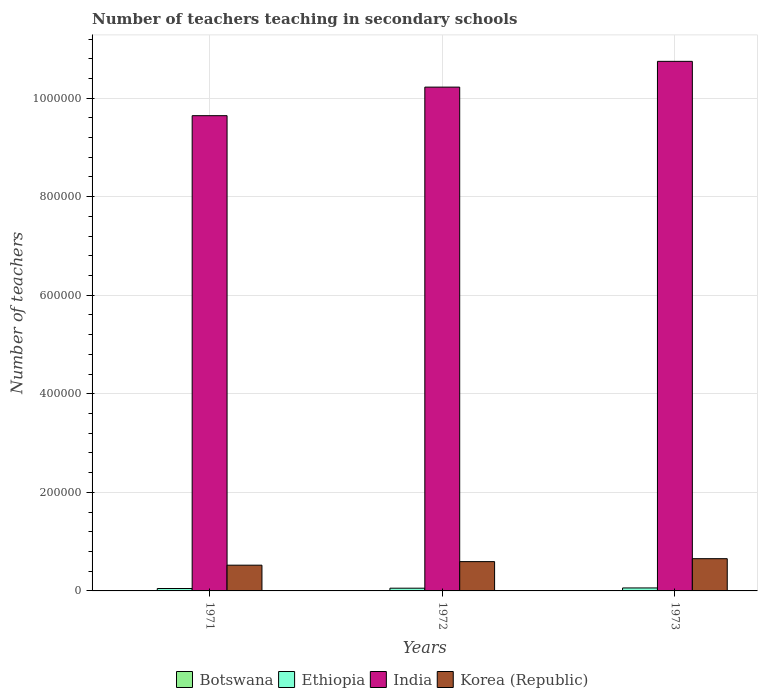How many different coloured bars are there?
Your response must be concise. 4. Are the number of bars per tick equal to the number of legend labels?
Keep it short and to the point. Yes. Are the number of bars on each tick of the X-axis equal?
Your answer should be very brief. Yes. How many bars are there on the 2nd tick from the left?
Provide a short and direct response. 4. How many bars are there on the 1st tick from the right?
Provide a succinct answer. 4. In how many cases, is the number of bars for a given year not equal to the number of legend labels?
Ensure brevity in your answer.  0. What is the number of teachers teaching in secondary schools in Korea (Republic) in 1972?
Provide a succinct answer. 5.95e+04. Across all years, what is the maximum number of teachers teaching in secondary schools in India?
Give a very brief answer. 1.07e+06. Across all years, what is the minimum number of teachers teaching in secondary schools in Ethiopia?
Offer a terse response. 4885. What is the total number of teachers teaching in secondary schools in Korea (Republic) in the graph?
Offer a terse response. 1.77e+05. What is the difference between the number of teachers teaching in secondary schools in Ethiopia in 1972 and that in 1973?
Your answer should be compact. -510. What is the difference between the number of teachers teaching in secondary schools in Ethiopia in 1973 and the number of teachers teaching in secondary schools in Korea (Republic) in 1972?
Your response must be concise. -5.34e+04. What is the average number of teachers teaching in secondary schools in India per year?
Offer a terse response. 1.02e+06. In the year 1971, what is the difference between the number of teachers teaching in secondary schools in India and number of teachers teaching in secondary schools in Ethiopia?
Your answer should be compact. 9.60e+05. In how many years, is the number of teachers teaching in secondary schools in India greater than 880000?
Ensure brevity in your answer.  3. What is the ratio of the number of teachers teaching in secondary schools in Botswana in 1972 to that in 1973?
Your answer should be compact. 0.8. What is the difference between the highest and the second highest number of teachers teaching in secondary schools in Botswana?
Your response must be concise. 119. What is the difference between the highest and the lowest number of teachers teaching in secondary schools in Korea (Republic)?
Your answer should be compact. 1.32e+04. In how many years, is the number of teachers teaching in secondary schools in Korea (Republic) greater than the average number of teachers teaching in secondary schools in Korea (Republic) taken over all years?
Provide a short and direct response. 2. Is the sum of the number of teachers teaching in secondary schools in Ethiopia in 1971 and 1972 greater than the maximum number of teachers teaching in secondary schools in Botswana across all years?
Your answer should be compact. Yes. What does the 3rd bar from the left in 1973 represents?
Provide a short and direct response. India. What does the 3rd bar from the right in 1971 represents?
Offer a very short reply. Ethiopia. Is it the case that in every year, the sum of the number of teachers teaching in secondary schools in Korea (Republic) and number of teachers teaching in secondary schools in Botswana is greater than the number of teachers teaching in secondary schools in Ethiopia?
Your answer should be compact. Yes. How many bars are there?
Your answer should be very brief. 12. Are all the bars in the graph horizontal?
Your answer should be very brief. No. How many years are there in the graph?
Your response must be concise. 3. What is the difference between two consecutive major ticks on the Y-axis?
Offer a very short reply. 2.00e+05. Does the graph contain grids?
Provide a short and direct response. Yes. Where does the legend appear in the graph?
Offer a terse response. Bottom center. How are the legend labels stacked?
Offer a terse response. Horizontal. What is the title of the graph?
Make the answer very short. Number of teachers teaching in secondary schools. What is the label or title of the Y-axis?
Provide a short and direct response. Number of teachers. What is the Number of teachers of Botswana in 1971?
Ensure brevity in your answer.  420. What is the Number of teachers of Ethiopia in 1971?
Give a very brief answer. 4885. What is the Number of teachers in India in 1971?
Give a very brief answer. 9.64e+05. What is the Number of teachers in Korea (Republic) in 1971?
Ensure brevity in your answer.  5.22e+04. What is the Number of teachers in Botswana in 1972?
Provide a succinct answer. 478. What is the Number of teachers in Ethiopia in 1972?
Offer a terse response. 5544. What is the Number of teachers of India in 1972?
Your answer should be very brief. 1.02e+06. What is the Number of teachers in Korea (Republic) in 1972?
Ensure brevity in your answer.  5.95e+04. What is the Number of teachers in Botswana in 1973?
Your answer should be compact. 597. What is the Number of teachers in Ethiopia in 1973?
Give a very brief answer. 6054. What is the Number of teachers in India in 1973?
Make the answer very short. 1.07e+06. What is the Number of teachers in Korea (Republic) in 1973?
Provide a succinct answer. 6.54e+04. Across all years, what is the maximum Number of teachers in Botswana?
Ensure brevity in your answer.  597. Across all years, what is the maximum Number of teachers of Ethiopia?
Provide a succinct answer. 6054. Across all years, what is the maximum Number of teachers in India?
Provide a succinct answer. 1.07e+06. Across all years, what is the maximum Number of teachers of Korea (Republic)?
Offer a terse response. 6.54e+04. Across all years, what is the minimum Number of teachers in Botswana?
Your response must be concise. 420. Across all years, what is the minimum Number of teachers of Ethiopia?
Keep it short and to the point. 4885. Across all years, what is the minimum Number of teachers in India?
Offer a terse response. 9.64e+05. Across all years, what is the minimum Number of teachers in Korea (Republic)?
Ensure brevity in your answer.  5.22e+04. What is the total Number of teachers in Botswana in the graph?
Offer a very short reply. 1495. What is the total Number of teachers of Ethiopia in the graph?
Provide a succinct answer. 1.65e+04. What is the total Number of teachers in India in the graph?
Your answer should be compact. 3.06e+06. What is the total Number of teachers in Korea (Republic) in the graph?
Your response must be concise. 1.77e+05. What is the difference between the Number of teachers of Botswana in 1971 and that in 1972?
Provide a succinct answer. -58. What is the difference between the Number of teachers in Ethiopia in 1971 and that in 1972?
Keep it short and to the point. -659. What is the difference between the Number of teachers in India in 1971 and that in 1972?
Offer a very short reply. -5.80e+04. What is the difference between the Number of teachers of Korea (Republic) in 1971 and that in 1972?
Ensure brevity in your answer.  -7222. What is the difference between the Number of teachers in Botswana in 1971 and that in 1973?
Ensure brevity in your answer.  -177. What is the difference between the Number of teachers of Ethiopia in 1971 and that in 1973?
Your answer should be compact. -1169. What is the difference between the Number of teachers in India in 1971 and that in 1973?
Provide a short and direct response. -1.10e+05. What is the difference between the Number of teachers in Korea (Republic) in 1971 and that in 1973?
Ensure brevity in your answer.  -1.32e+04. What is the difference between the Number of teachers of Botswana in 1972 and that in 1973?
Provide a short and direct response. -119. What is the difference between the Number of teachers of Ethiopia in 1972 and that in 1973?
Your answer should be very brief. -510. What is the difference between the Number of teachers in India in 1972 and that in 1973?
Provide a short and direct response. -5.23e+04. What is the difference between the Number of teachers in Korea (Republic) in 1972 and that in 1973?
Ensure brevity in your answer.  -5988. What is the difference between the Number of teachers in Botswana in 1971 and the Number of teachers in Ethiopia in 1972?
Your answer should be very brief. -5124. What is the difference between the Number of teachers in Botswana in 1971 and the Number of teachers in India in 1972?
Ensure brevity in your answer.  -1.02e+06. What is the difference between the Number of teachers in Botswana in 1971 and the Number of teachers in Korea (Republic) in 1972?
Provide a succinct answer. -5.90e+04. What is the difference between the Number of teachers of Ethiopia in 1971 and the Number of teachers of India in 1972?
Offer a terse response. -1.02e+06. What is the difference between the Number of teachers of Ethiopia in 1971 and the Number of teachers of Korea (Republic) in 1972?
Keep it short and to the point. -5.46e+04. What is the difference between the Number of teachers in India in 1971 and the Number of teachers in Korea (Republic) in 1972?
Give a very brief answer. 9.05e+05. What is the difference between the Number of teachers in Botswana in 1971 and the Number of teachers in Ethiopia in 1973?
Provide a short and direct response. -5634. What is the difference between the Number of teachers in Botswana in 1971 and the Number of teachers in India in 1973?
Keep it short and to the point. -1.07e+06. What is the difference between the Number of teachers in Botswana in 1971 and the Number of teachers in Korea (Republic) in 1973?
Keep it short and to the point. -6.50e+04. What is the difference between the Number of teachers in Ethiopia in 1971 and the Number of teachers in India in 1973?
Your answer should be compact. -1.07e+06. What is the difference between the Number of teachers of Ethiopia in 1971 and the Number of teachers of Korea (Republic) in 1973?
Ensure brevity in your answer.  -6.06e+04. What is the difference between the Number of teachers of India in 1971 and the Number of teachers of Korea (Republic) in 1973?
Offer a very short reply. 8.99e+05. What is the difference between the Number of teachers of Botswana in 1972 and the Number of teachers of Ethiopia in 1973?
Your response must be concise. -5576. What is the difference between the Number of teachers in Botswana in 1972 and the Number of teachers in India in 1973?
Provide a short and direct response. -1.07e+06. What is the difference between the Number of teachers in Botswana in 1972 and the Number of teachers in Korea (Republic) in 1973?
Your answer should be compact. -6.50e+04. What is the difference between the Number of teachers in Ethiopia in 1972 and the Number of teachers in India in 1973?
Provide a short and direct response. -1.07e+06. What is the difference between the Number of teachers of Ethiopia in 1972 and the Number of teachers of Korea (Republic) in 1973?
Keep it short and to the point. -5.99e+04. What is the difference between the Number of teachers of India in 1972 and the Number of teachers of Korea (Republic) in 1973?
Your answer should be compact. 9.57e+05. What is the average Number of teachers of Botswana per year?
Give a very brief answer. 498.33. What is the average Number of teachers in Ethiopia per year?
Offer a terse response. 5494.33. What is the average Number of teachers in India per year?
Your response must be concise. 1.02e+06. What is the average Number of teachers in Korea (Republic) per year?
Provide a short and direct response. 5.90e+04. In the year 1971, what is the difference between the Number of teachers in Botswana and Number of teachers in Ethiopia?
Offer a terse response. -4465. In the year 1971, what is the difference between the Number of teachers of Botswana and Number of teachers of India?
Provide a short and direct response. -9.64e+05. In the year 1971, what is the difference between the Number of teachers in Botswana and Number of teachers in Korea (Republic)?
Ensure brevity in your answer.  -5.18e+04. In the year 1971, what is the difference between the Number of teachers of Ethiopia and Number of teachers of India?
Offer a very short reply. -9.60e+05. In the year 1971, what is the difference between the Number of teachers in Ethiopia and Number of teachers in Korea (Republic)?
Your answer should be very brief. -4.73e+04. In the year 1971, what is the difference between the Number of teachers in India and Number of teachers in Korea (Republic)?
Your response must be concise. 9.12e+05. In the year 1972, what is the difference between the Number of teachers of Botswana and Number of teachers of Ethiopia?
Provide a succinct answer. -5066. In the year 1972, what is the difference between the Number of teachers in Botswana and Number of teachers in India?
Your answer should be compact. -1.02e+06. In the year 1972, what is the difference between the Number of teachers of Botswana and Number of teachers of Korea (Republic)?
Offer a terse response. -5.90e+04. In the year 1972, what is the difference between the Number of teachers of Ethiopia and Number of teachers of India?
Your answer should be very brief. -1.02e+06. In the year 1972, what is the difference between the Number of teachers in Ethiopia and Number of teachers in Korea (Republic)?
Provide a succinct answer. -5.39e+04. In the year 1972, what is the difference between the Number of teachers in India and Number of teachers in Korea (Republic)?
Give a very brief answer. 9.63e+05. In the year 1973, what is the difference between the Number of teachers of Botswana and Number of teachers of Ethiopia?
Your answer should be compact. -5457. In the year 1973, what is the difference between the Number of teachers in Botswana and Number of teachers in India?
Provide a short and direct response. -1.07e+06. In the year 1973, what is the difference between the Number of teachers in Botswana and Number of teachers in Korea (Republic)?
Give a very brief answer. -6.48e+04. In the year 1973, what is the difference between the Number of teachers in Ethiopia and Number of teachers in India?
Your answer should be very brief. -1.07e+06. In the year 1973, what is the difference between the Number of teachers in Ethiopia and Number of teachers in Korea (Republic)?
Your answer should be compact. -5.94e+04. In the year 1973, what is the difference between the Number of teachers of India and Number of teachers of Korea (Republic)?
Ensure brevity in your answer.  1.01e+06. What is the ratio of the Number of teachers of Botswana in 1971 to that in 1972?
Your response must be concise. 0.88. What is the ratio of the Number of teachers in Ethiopia in 1971 to that in 1972?
Provide a succinct answer. 0.88. What is the ratio of the Number of teachers of India in 1971 to that in 1972?
Give a very brief answer. 0.94. What is the ratio of the Number of teachers in Korea (Republic) in 1971 to that in 1972?
Offer a very short reply. 0.88. What is the ratio of the Number of teachers of Botswana in 1971 to that in 1973?
Ensure brevity in your answer.  0.7. What is the ratio of the Number of teachers in Ethiopia in 1971 to that in 1973?
Your answer should be very brief. 0.81. What is the ratio of the Number of teachers of India in 1971 to that in 1973?
Give a very brief answer. 0.9. What is the ratio of the Number of teachers of Korea (Republic) in 1971 to that in 1973?
Give a very brief answer. 0.8. What is the ratio of the Number of teachers in Botswana in 1972 to that in 1973?
Provide a succinct answer. 0.8. What is the ratio of the Number of teachers of Ethiopia in 1972 to that in 1973?
Provide a succinct answer. 0.92. What is the ratio of the Number of teachers of India in 1972 to that in 1973?
Your answer should be compact. 0.95. What is the ratio of the Number of teachers of Korea (Republic) in 1972 to that in 1973?
Ensure brevity in your answer.  0.91. What is the difference between the highest and the second highest Number of teachers of Botswana?
Your answer should be very brief. 119. What is the difference between the highest and the second highest Number of teachers of Ethiopia?
Provide a succinct answer. 510. What is the difference between the highest and the second highest Number of teachers in India?
Provide a succinct answer. 5.23e+04. What is the difference between the highest and the second highest Number of teachers of Korea (Republic)?
Make the answer very short. 5988. What is the difference between the highest and the lowest Number of teachers in Botswana?
Make the answer very short. 177. What is the difference between the highest and the lowest Number of teachers of Ethiopia?
Provide a succinct answer. 1169. What is the difference between the highest and the lowest Number of teachers of India?
Provide a succinct answer. 1.10e+05. What is the difference between the highest and the lowest Number of teachers of Korea (Republic)?
Provide a succinct answer. 1.32e+04. 